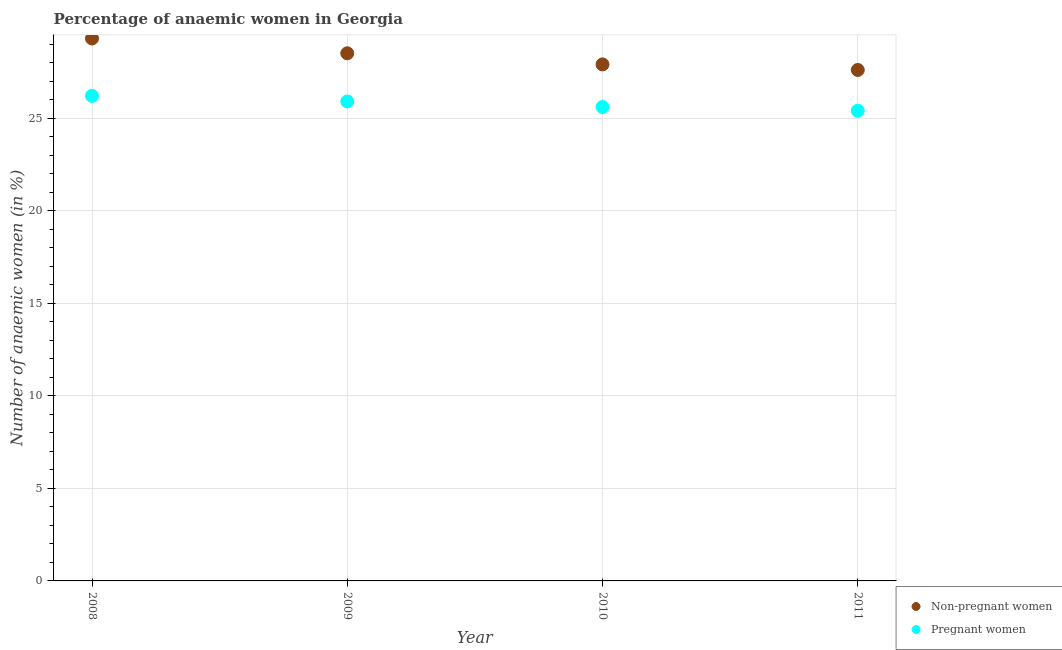What is the percentage of pregnant anaemic women in 2009?
Provide a succinct answer. 25.9. Across all years, what is the maximum percentage of non-pregnant anaemic women?
Provide a succinct answer. 29.3. Across all years, what is the minimum percentage of non-pregnant anaemic women?
Make the answer very short. 27.6. In which year was the percentage of pregnant anaemic women minimum?
Offer a terse response. 2011. What is the total percentage of pregnant anaemic women in the graph?
Your response must be concise. 103.1. What is the difference between the percentage of pregnant anaemic women in 2010 and that in 2011?
Your answer should be very brief. 0.2. What is the difference between the percentage of non-pregnant anaemic women in 2010 and the percentage of pregnant anaemic women in 2008?
Offer a terse response. 1.7. What is the average percentage of pregnant anaemic women per year?
Keep it short and to the point. 25.77. In the year 2011, what is the difference between the percentage of pregnant anaemic women and percentage of non-pregnant anaemic women?
Your answer should be very brief. -2.2. In how many years, is the percentage of non-pregnant anaemic women greater than 12 %?
Keep it short and to the point. 4. What is the ratio of the percentage of non-pregnant anaemic women in 2009 to that in 2010?
Your answer should be very brief. 1.02. What is the difference between the highest and the second highest percentage of pregnant anaemic women?
Give a very brief answer. 0.3. What is the difference between the highest and the lowest percentage of pregnant anaemic women?
Your response must be concise. 0.8. Is the percentage of pregnant anaemic women strictly greater than the percentage of non-pregnant anaemic women over the years?
Provide a short and direct response. No. Is the percentage of non-pregnant anaemic women strictly less than the percentage of pregnant anaemic women over the years?
Give a very brief answer. No. How many dotlines are there?
Keep it short and to the point. 2. What is the difference between two consecutive major ticks on the Y-axis?
Ensure brevity in your answer.  5. Does the graph contain grids?
Give a very brief answer. Yes. How many legend labels are there?
Offer a terse response. 2. How are the legend labels stacked?
Keep it short and to the point. Vertical. What is the title of the graph?
Keep it short and to the point. Percentage of anaemic women in Georgia. Does "IMF nonconcessional" appear as one of the legend labels in the graph?
Ensure brevity in your answer.  No. What is the label or title of the X-axis?
Your answer should be very brief. Year. What is the label or title of the Y-axis?
Offer a terse response. Number of anaemic women (in %). What is the Number of anaemic women (in %) of Non-pregnant women in 2008?
Keep it short and to the point. 29.3. What is the Number of anaemic women (in %) of Pregnant women in 2008?
Provide a succinct answer. 26.2. What is the Number of anaemic women (in %) in Non-pregnant women in 2009?
Keep it short and to the point. 28.5. What is the Number of anaemic women (in %) in Pregnant women in 2009?
Provide a succinct answer. 25.9. What is the Number of anaemic women (in %) in Non-pregnant women in 2010?
Give a very brief answer. 27.9. What is the Number of anaemic women (in %) in Pregnant women in 2010?
Provide a succinct answer. 25.6. What is the Number of anaemic women (in %) of Non-pregnant women in 2011?
Provide a short and direct response. 27.6. What is the Number of anaemic women (in %) in Pregnant women in 2011?
Your answer should be very brief. 25.4. Across all years, what is the maximum Number of anaemic women (in %) in Non-pregnant women?
Provide a succinct answer. 29.3. Across all years, what is the maximum Number of anaemic women (in %) in Pregnant women?
Keep it short and to the point. 26.2. Across all years, what is the minimum Number of anaemic women (in %) in Non-pregnant women?
Keep it short and to the point. 27.6. Across all years, what is the minimum Number of anaemic women (in %) of Pregnant women?
Provide a succinct answer. 25.4. What is the total Number of anaemic women (in %) of Non-pregnant women in the graph?
Give a very brief answer. 113.3. What is the total Number of anaemic women (in %) of Pregnant women in the graph?
Make the answer very short. 103.1. What is the difference between the Number of anaemic women (in %) of Non-pregnant women in 2008 and that in 2009?
Your answer should be very brief. 0.8. What is the difference between the Number of anaemic women (in %) in Pregnant women in 2008 and that in 2009?
Offer a very short reply. 0.3. What is the difference between the Number of anaemic women (in %) of Non-pregnant women in 2008 and that in 2010?
Your answer should be compact. 1.4. What is the difference between the Number of anaemic women (in %) in Pregnant women in 2008 and that in 2010?
Provide a succinct answer. 0.6. What is the difference between the Number of anaemic women (in %) of Pregnant women in 2008 and that in 2011?
Give a very brief answer. 0.8. What is the difference between the Number of anaemic women (in %) of Pregnant women in 2009 and that in 2010?
Provide a short and direct response. 0.3. What is the difference between the Number of anaemic women (in %) of Non-pregnant women in 2010 and that in 2011?
Make the answer very short. 0.3. What is the difference between the Number of anaemic women (in %) in Pregnant women in 2010 and that in 2011?
Your response must be concise. 0.2. What is the difference between the Number of anaemic women (in %) of Non-pregnant women in 2008 and the Number of anaemic women (in %) of Pregnant women in 2010?
Make the answer very short. 3.7. What is the difference between the Number of anaemic women (in %) in Non-pregnant women in 2010 and the Number of anaemic women (in %) in Pregnant women in 2011?
Your response must be concise. 2.5. What is the average Number of anaemic women (in %) in Non-pregnant women per year?
Give a very brief answer. 28.32. What is the average Number of anaemic women (in %) of Pregnant women per year?
Make the answer very short. 25.77. In the year 2008, what is the difference between the Number of anaemic women (in %) in Non-pregnant women and Number of anaemic women (in %) in Pregnant women?
Offer a very short reply. 3.1. In the year 2009, what is the difference between the Number of anaemic women (in %) of Non-pregnant women and Number of anaemic women (in %) of Pregnant women?
Ensure brevity in your answer.  2.6. In the year 2011, what is the difference between the Number of anaemic women (in %) in Non-pregnant women and Number of anaemic women (in %) in Pregnant women?
Give a very brief answer. 2.2. What is the ratio of the Number of anaemic women (in %) in Non-pregnant women in 2008 to that in 2009?
Give a very brief answer. 1.03. What is the ratio of the Number of anaemic women (in %) of Pregnant women in 2008 to that in 2009?
Your answer should be very brief. 1.01. What is the ratio of the Number of anaemic women (in %) in Non-pregnant women in 2008 to that in 2010?
Make the answer very short. 1.05. What is the ratio of the Number of anaemic women (in %) in Pregnant women in 2008 to that in 2010?
Make the answer very short. 1.02. What is the ratio of the Number of anaemic women (in %) of Non-pregnant women in 2008 to that in 2011?
Offer a terse response. 1.06. What is the ratio of the Number of anaemic women (in %) of Pregnant women in 2008 to that in 2011?
Ensure brevity in your answer.  1.03. What is the ratio of the Number of anaemic women (in %) in Non-pregnant women in 2009 to that in 2010?
Offer a terse response. 1.02. What is the ratio of the Number of anaemic women (in %) in Pregnant women in 2009 to that in 2010?
Keep it short and to the point. 1.01. What is the ratio of the Number of anaemic women (in %) in Non-pregnant women in 2009 to that in 2011?
Offer a terse response. 1.03. What is the ratio of the Number of anaemic women (in %) of Pregnant women in 2009 to that in 2011?
Provide a succinct answer. 1.02. What is the ratio of the Number of anaemic women (in %) of Non-pregnant women in 2010 to that in 2011?
Your answer should be very brief. 1.01. What is the ratio of the Number of anaemic women (in %) in Pregnant women in 2010 to that in 2011?
Offer a terse response. 1.01. What is the difference between the highest and the second highest Number of anaemic women (in %) in Pregnant women?
Provide a short and direct response. 0.3. What is the difference between the highest and the lowest Number of anaemic women (in %) of Non-pregnant women?
Offer a terse response. 1.7. 